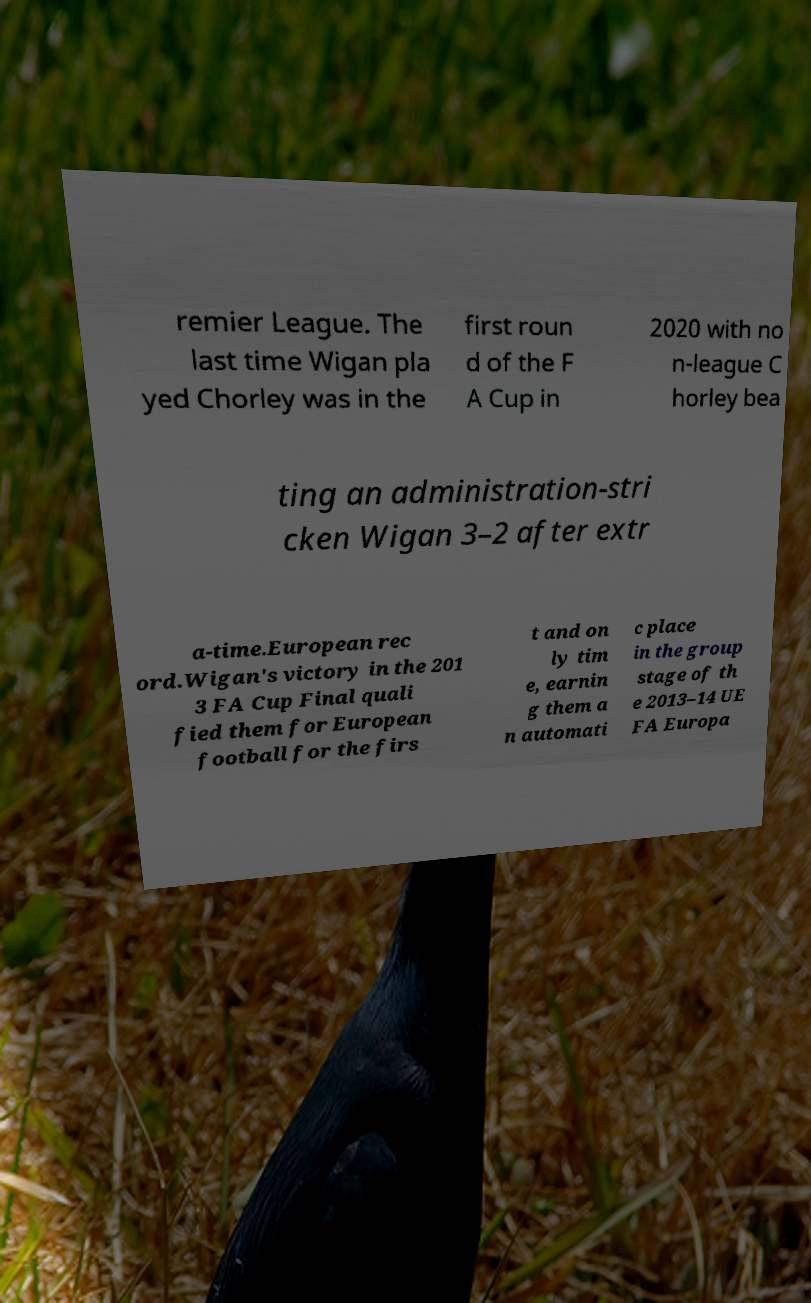Can you read and provide the text displayed in the image?This photo seems to have some interesting text. Can you extract and type it out for me? remier League. The last time Wigan pla yed Chorley was in the first roun d of the F A Cup in 2020 with no n-league C horley bea ting an administration-stri cken Wigan 3–2 after extr a-time.European rec ord.Wigan's victory in the 201 3 FA Cup Final quali fied them for European football for the firs t and on ly tim e, earnin g them a n automati c place in the group stage of th e 2013–14 UE FA Europa 